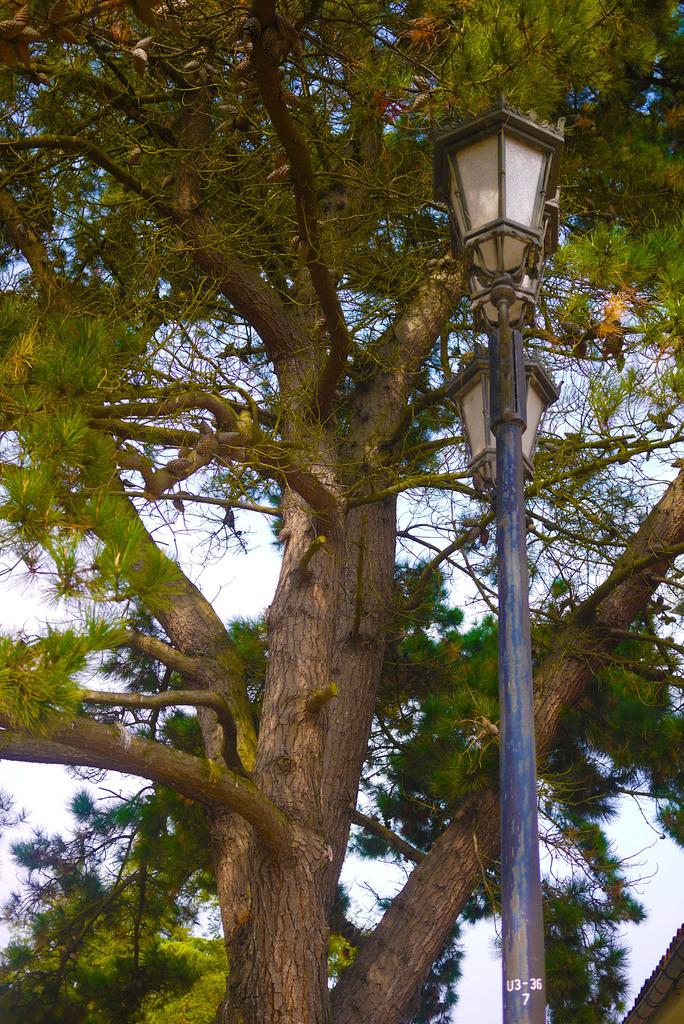What type of plant can be seen in the image? There is a tree in the image. What kind of lighting is present in the image? There are lantern lamps with poles in the image. What part of the natural environment is visible in the image? The sky is visible in the image. What type of market is depicted in the image? There is no market present in the image; it features a tree, lantern lamps with poles, and the sky. 